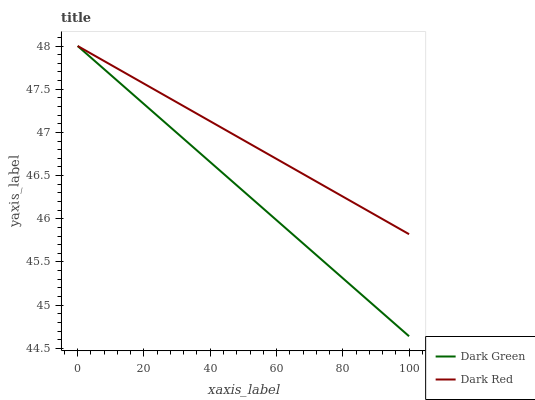Does Dark Green have the minimum area under the curve?
Answer yes or no. Yes. Does Dark Red have the maximum area under the curve?
Answer yes or no. Yes. Does Dark Green have the maximum area under the curve?
Answer yes or no. No. Is Dark Green the smoothest?
Answer yes or no. Yes. Is Dark Red the roughest?
Answer yes or no. Yes. Is Dark Green the roughest?
Answer yes or no. No. Does Dark Green have the lowest value?
Answer yes or no. Yes. Does Dark Green have the highest value?
Answer yes or no. Yes. Does Dark Green intersect Dark Red?
Answer yes or no. Yes. Is Dark Green less than Dark Red?
Answer yes or no. No. Is Dark Green greater than Dark Red?
Answer yes or no. No. 